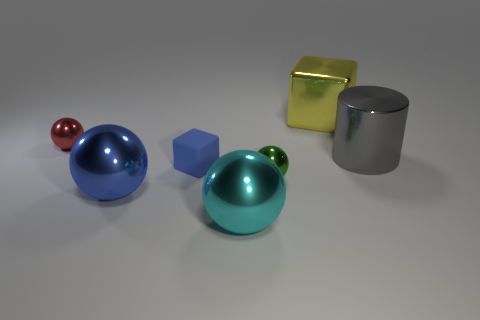Are there any small metal spheres that have the same color as the tiny matte cube?
Make the answer very short. No. What number of big metal spheres are left of the small ball that is behind the tiny green metallic thing?
Your answer should be very brief. 0. Is the number of blue rubber objects greater than the number of tiny gray rubber blocks?
Provide a succinct answer. Yes. Do the red ball and the small blue object have the same material?
Give a very brief answer. No. Is the number of small green metallic spheres that are in front of the green object the same as the number of large gray objects?
Offer a terse response. No. How many large cyan objects have the same material as the big yellow thing?
Give a very brief answer. 1. Are there fewer tiny green shiny spheres than big purple metallic cylinders?
Your answer should be compact. No. There is a large metal thing that is left of the tiny blue object; does it have the same color as the tiny matte object?
Ensure brevity in your answer.  Yes. What number of large gray metallic cylinders are behind the tiny metal object that is to the left of the block on the left side of the big yellow block?
Provide a succinct answer. 0. There is a tiny red metallic object; what number of things are on the left side of it?
Your answer should be compact. 0. 